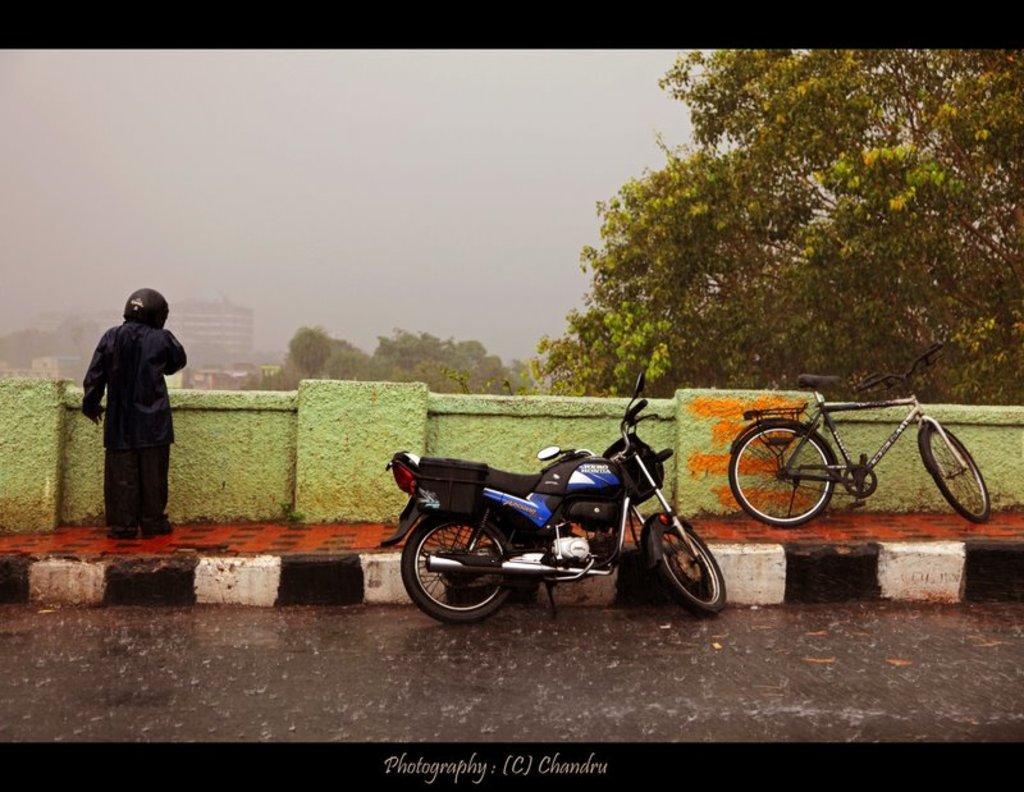Describe this image in one or two sentences. In this image we can see a person wearing a helmet and standing on the pavement, there is a bicycle near the wall and a motorbike on the road and there are few trees, buildings and the sky in the background. 